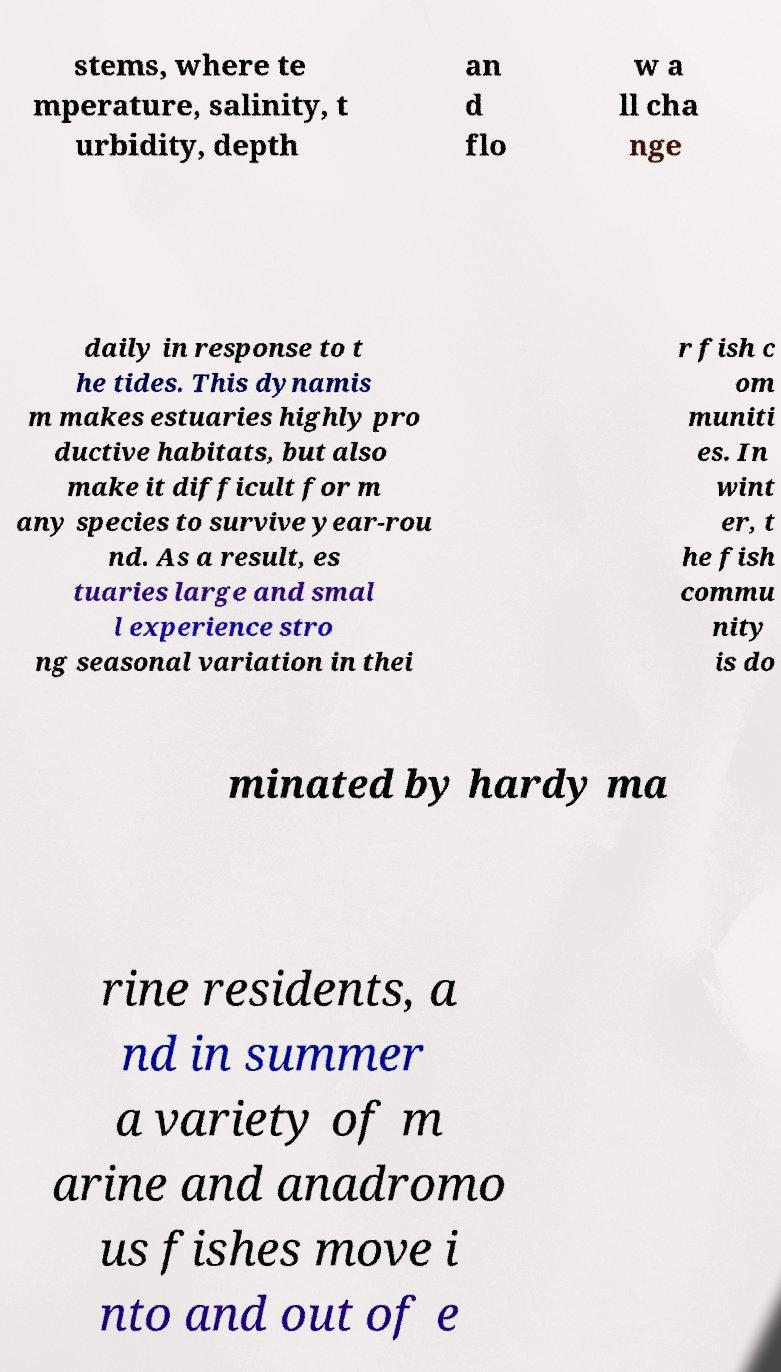I need the written content from this picture converted into text. Can you do that? stems, where te mperature, salinity, t urbidity, depth an d flo w a ll cha nge daily in response to t he tides. This dynamis m makes estuaries highly pro ductive habitats, but also make it difficult for m any species to survive year-rou nd. As a result, es tuaries large and smal l experience stro ng seasonal variation in thei r fish c om muniti es. In wint er, t he fish commu nity is do minated by hardy ma rine residents, a nd in summer a variety of m arine and anadromo us fishes move i nto and out of e 